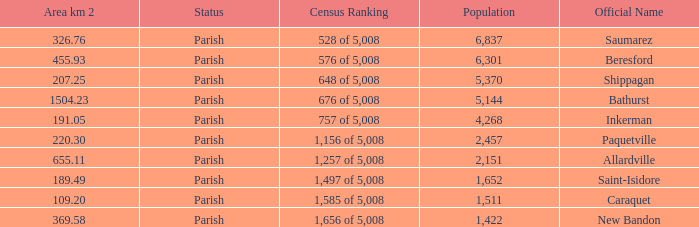What is the Population of the New Bandon Parish with an Area km 2 larger than 326.76? 1422.0. 